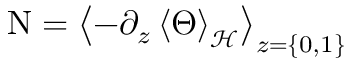<formula> <loc_0><loc_0><loc_500><loc_500>\nu = \left < - \partial _ { z } \left < \Theta \right > _ { \mathcal { H } } \right > _ { z = \{ 0 , 1 \} }</formula> 